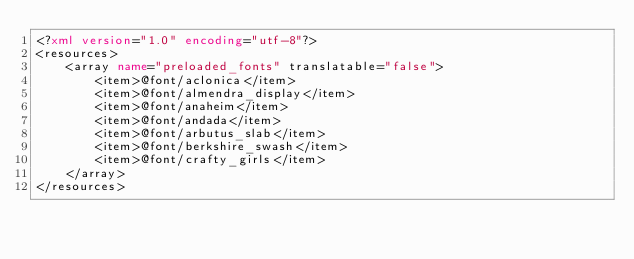Convert code to text. <code><loc_0><loc_0><loc_500><loc_500><_XML_><?xml version="1.0" encoding="utf-8"?>
<resources>
    <array name="preloaded_fonts" translatable="false">
        <item>@font/aclonica</item>
        <item>@font/almendra_display</item>
        <item>@font/anaheim</item>
        <item>@font/andada</item>
        <item>@font/arbutus_slab</item>
        <item>@font/berkshire_swash</item>
        <item>@font/crafty_girls</item>
    </array>
</resources>
</code> 